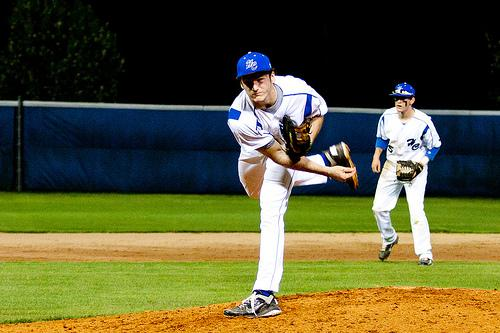Question: what brand shoe is the pitcher wearing?
Choices:
A. Reebok.
B. Converse.
C. Lotto.
D. Nike.
Answer with the letter. Answer: D Question: what two colors is the uniform?
Choices:
A. Black and red.
B. White and red.
C. Yellow and blue.
D. White and blue.
Answer with the letter. Answer: D 